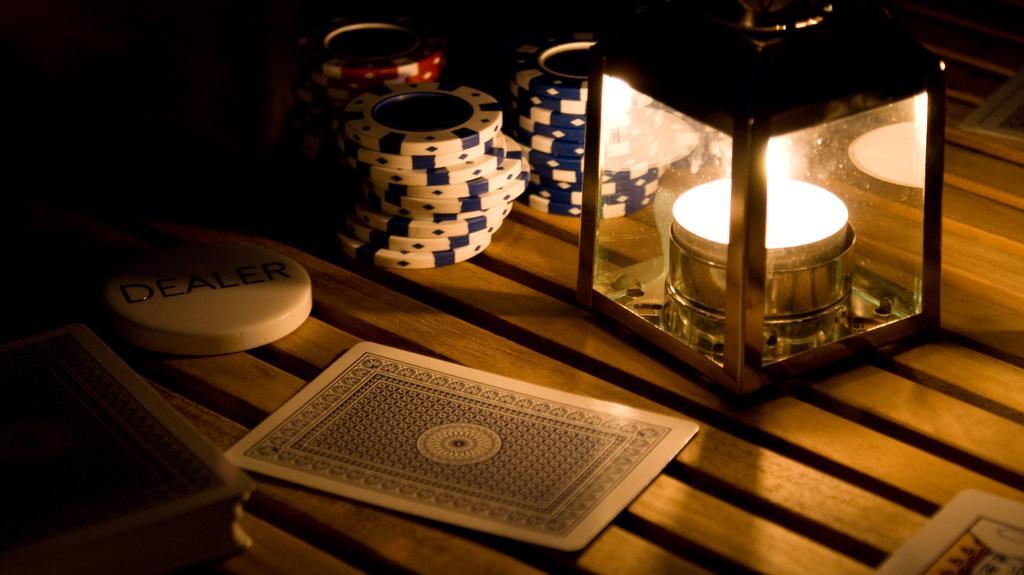How would you summarize this image in a sentence or two? In the center of the image we can see a table. On the table we can see cards, coins and a lamp are present. 